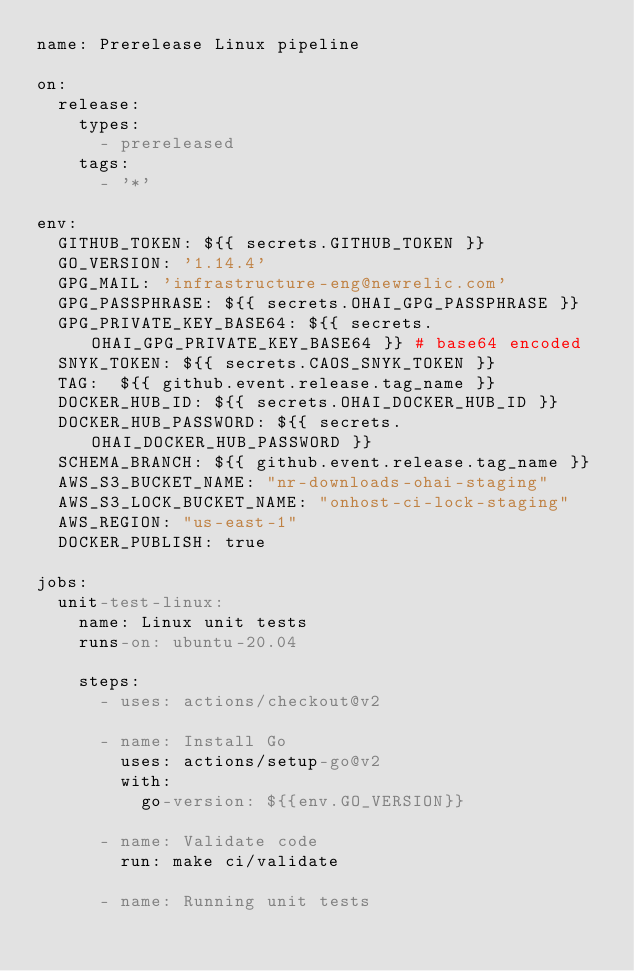Convert code to text. <code><loc_0><loc_0><loc_500><loc_500><_YAML_>name: Prerelease Linux pipeline

on:
  release:
    types:
      - prereleased
    tags:
      - '*'

env:
  GITHUB_TOKEN: ${{ secrets.GITHUB_TOKEN }}
  GO_VERSION: '1.14.4'
  GPG_MAIL: 'infrastructure-eng@newrelic.com'
  GPG_PASSPHRASE: ${{ secrets.OHAI_GPG_PASSPHRASE }}
  GPG_PRIVATE_KEY_BASE64: ${{ secrets.OHAI_GPG_PRIVATE_KEY_BASE64 }} # base64 encoded
  SNYK_TOKEN: ${{ secrets.CAOS_SNYK_TOKEN }}
  TAG:  ${{ github.event.release.tag_name }}
  DOCKER_HUB_ID: ${{ secrets.OHAI_DOCKER_HUB_ID }}
  DOCKER_HUB_PASSWORD: ${{ secrets.OHAI_DOCKER_HUB_PASSWORD }}
  SCHEMA_BRANCH: ${{ github.event.release.tag_name }}
  AWS_S3_BUCKET_NAME: "nr-downloads-ohai-staging"
  AWS_S3_LOCK_BUCKET_NAME: "onhost-ci-lock-staging"
  AWS_REGION: "us-east-1"
  DOCKER_PUBLISH: true

jobs:
  unit-test-linux:
    name: Linux unit tests
    runs-on: ubuntu-20.04

    steps:
      - uses: actions/checkout@v2

      - name: Install Go
        uses: actions/setup-go@v2
        with:
          go-version: ${{env.GO_VERSION}}

      - name: Validate code
        run: make ci/validate

      - name: Running unit tests</code> 